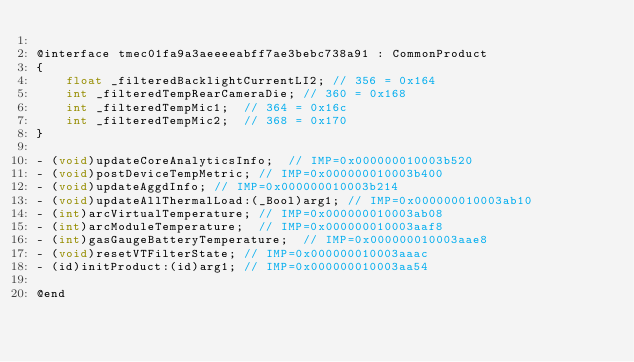<code> <loc_0><loc_0><loc_500><loc_500><_C_>
@interface tmec01fa9a3aeeeeabff7ae3bebc738a91 : CommonProduct
{
    float _filteredBacklightCurrentLI2;	// 356 = 0x164
    int _filteredTempRearCameraDie;	// 360 = 0x168
    int _filteredTempMic1;	// 364 = 0x16c
    int _filteredTempMic2;	// 368 = 0x170
}

- (void)updateCoreAnalyticsInfo;	// IMP=0x000000010003b520
- (void)postDeviceTempMetric;	// IMP=0x000000010003b400
- (void)updateAggdInfo;	// IMP=0x000000010003b214
- (void)updateAllThermalLoad:(_Bool)arg1;	// IMP=0x000000010003ab10
- (int)arcVirtualTemperature;	// IMP=0x000000010003ab08
- (int)arcModuleTemperature;	// IMP=0x000000010003aaf8
- (int)gasGaugeBatteryTemperature;	// IMP=0x000000010003aae8
- (void)resetVTFilterState;	// IMP=0x000000010003aaac
- (id)initProduct:(id)arg1;	// IMP=0x000000010003aa54

@end

</code> 